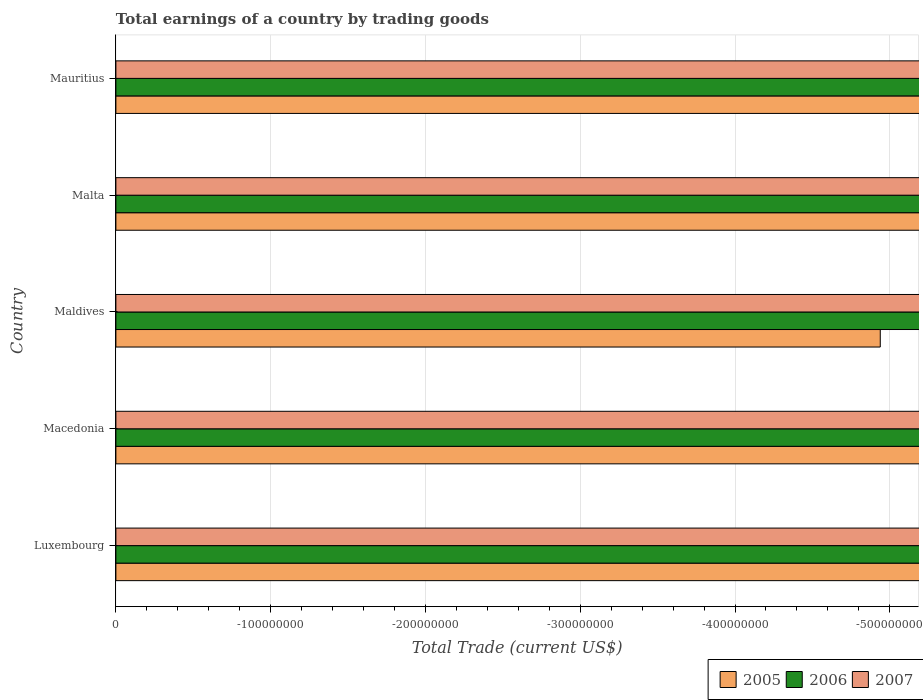How many different coloured bars are there?
Make the answer very short. 0. Are the number of bars on each tick of the Y-axis equal?
Provide a short and direct response. Yes. How many bars are there on the 3rd tick from the top?
Make the answer very short. 0. How many bars are there on the 2nd tick from the bottom?
Provide a short and direct response. 0. What is the label of the 5th group of bars from the top?
Offer a very short reply. Luxembourg. In how many cases, is the number of bars for a given country not equal to the number of legend labels?
Provide a short and direct response. 5. In how many countries, is the total earnings in 2007 greater than the average total earnings in 2007 taken over all countries?
Make the answer very short. 0. Is it the case that in every country, the sum of the total earnings in 2007 and total earnings in 2005 is greater than the total earnings in 2006?
Your answer should be very brief. No. How many bars are there?
Give a very brief answer. 0. Are all the bars in the graph horizontal?
Provide a short and direct response. Yes. Does the graph contain grids?
Your response must be concise. Yes. How are the legend labels stacked?
Give a very brief answer. Horizontal. What is the title of the graph?
Make the answer very short. Total earnings of a country by trading goods. Does "1970" appear as one of the legend labels in the graph?
Your answer should be very brief. No. What is the label or title of the X-axis?
Give a very brief answer. Total Trade (current US$). What is the Total Trade (current US$) in 2006 in Luxembourg?
Ensure brevity in your answer.  0. What is the Total Trade (current US$) in 2007 in Luxembourg?
Ensure brevity in your answer.  0. What is the Total Trade (current US$) of 2006 in Macedonia?
Make the answer very short. 0. What is the Total Trade (current US$) of 2005 in Malta?
Offer a very short reply. 0. What is the Total Trade (current US$) of 2006 in Malta?
Your response must be concise. 0. What is the total Total Trade (current US$) of 2007 in the graph?
Offer a terse response. 0. What is the average Total Trade (current US$) in 2005 per country?
Your response must be concise. 0. What is the average Total Trade (current US$) of 2006 per country?
Provide a succinct answer. 0. What is the average Total Trade (current US$) of 2007 per country?
Provide a short and direct response. 0. 